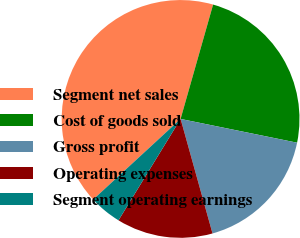Convert chart to OTSL. <chart><loc_0><loc_0><loc_500><loc_500><pie_chart><fcel>Segment net sales<fcel>Cost of goods sold<fcel>Gross profit<fcel>Operating expenses<fcel>Segment operating earnings<nl><fcel>41.26%<fcel>23.79%<fcel>17.47%<fcel>13.07%<fcel>4.4%<nl></chart> 